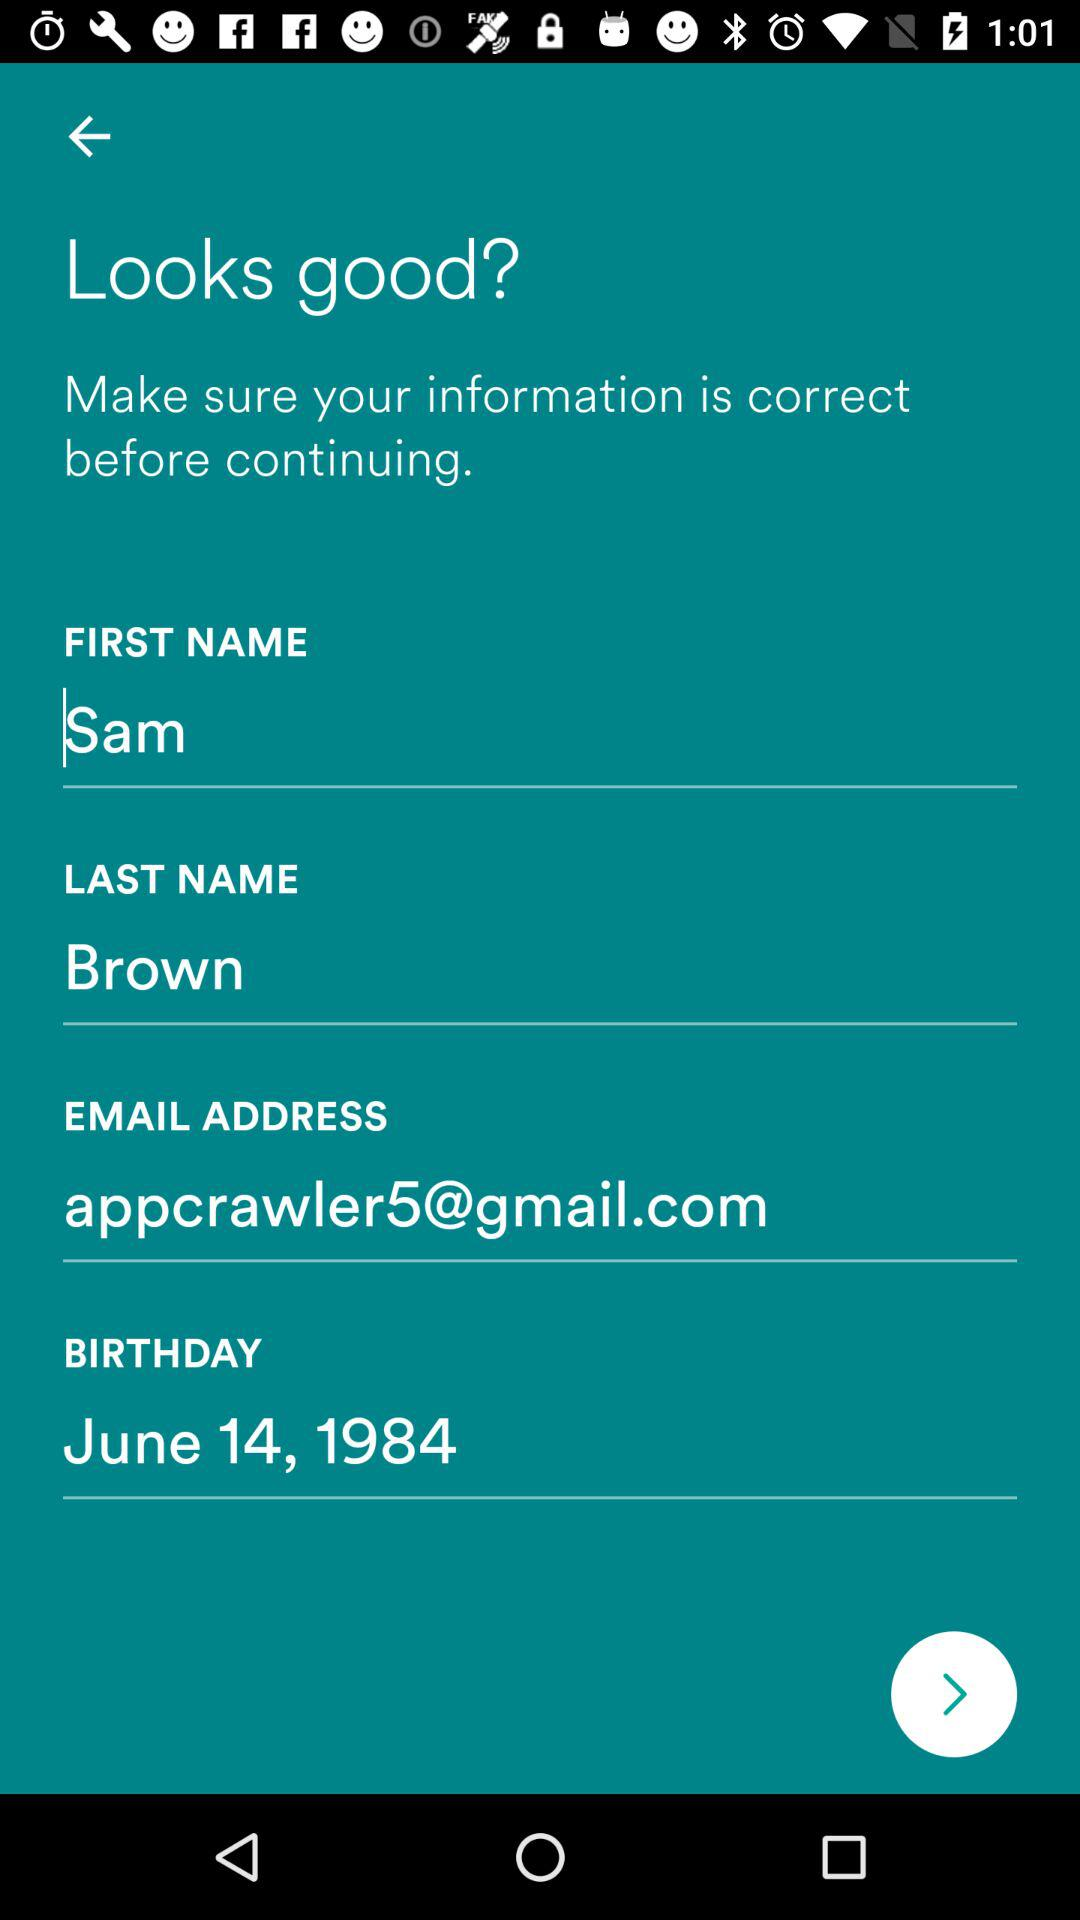How many text inputs have an email address in them?
Answer the question using a single word or phrase. 1 